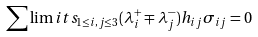Convert formula to latex. <formula><loc_0><loc_0><loc_500><loc_500>\sum \lim i t s _ { 1 \leq i , j \leq 3 } ( \lambda _ { i } ^ { + } \mp \lambda ^ { - } _ { j } ) h _ { i j } \sigma _ { i j } = 0</formula> 